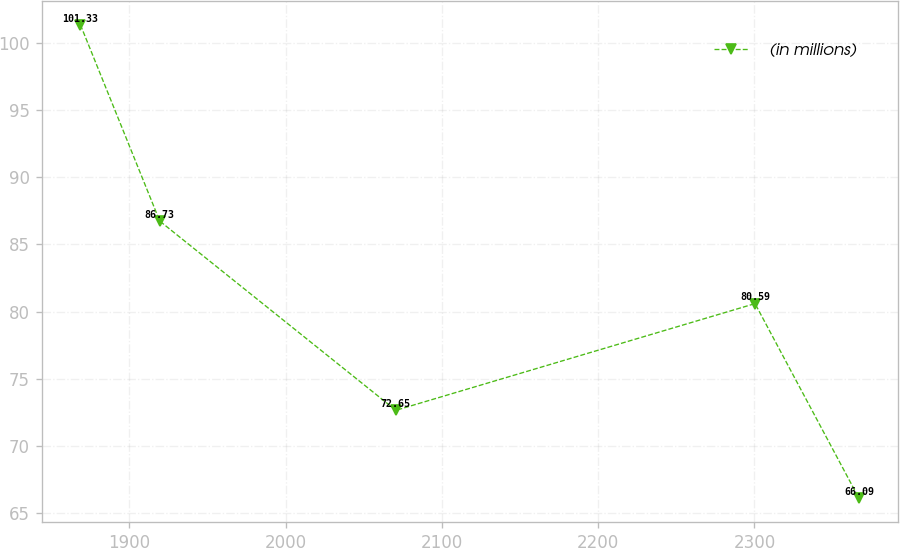Convert chart. <chart><loc_0><loc_0><loc_500><loc_500><line_chart><ecel><fcel>(in millions)<nl><fcel>1868.71<fcel>101.33<nl><fcel>1919.46<fcel>86.73<nl><fcel>2070.56<fcel>72.65<nl><fcel>2300.39<fcel>80.59<nl><fcel>2366.97<fcel>66.09<nl></chart> 